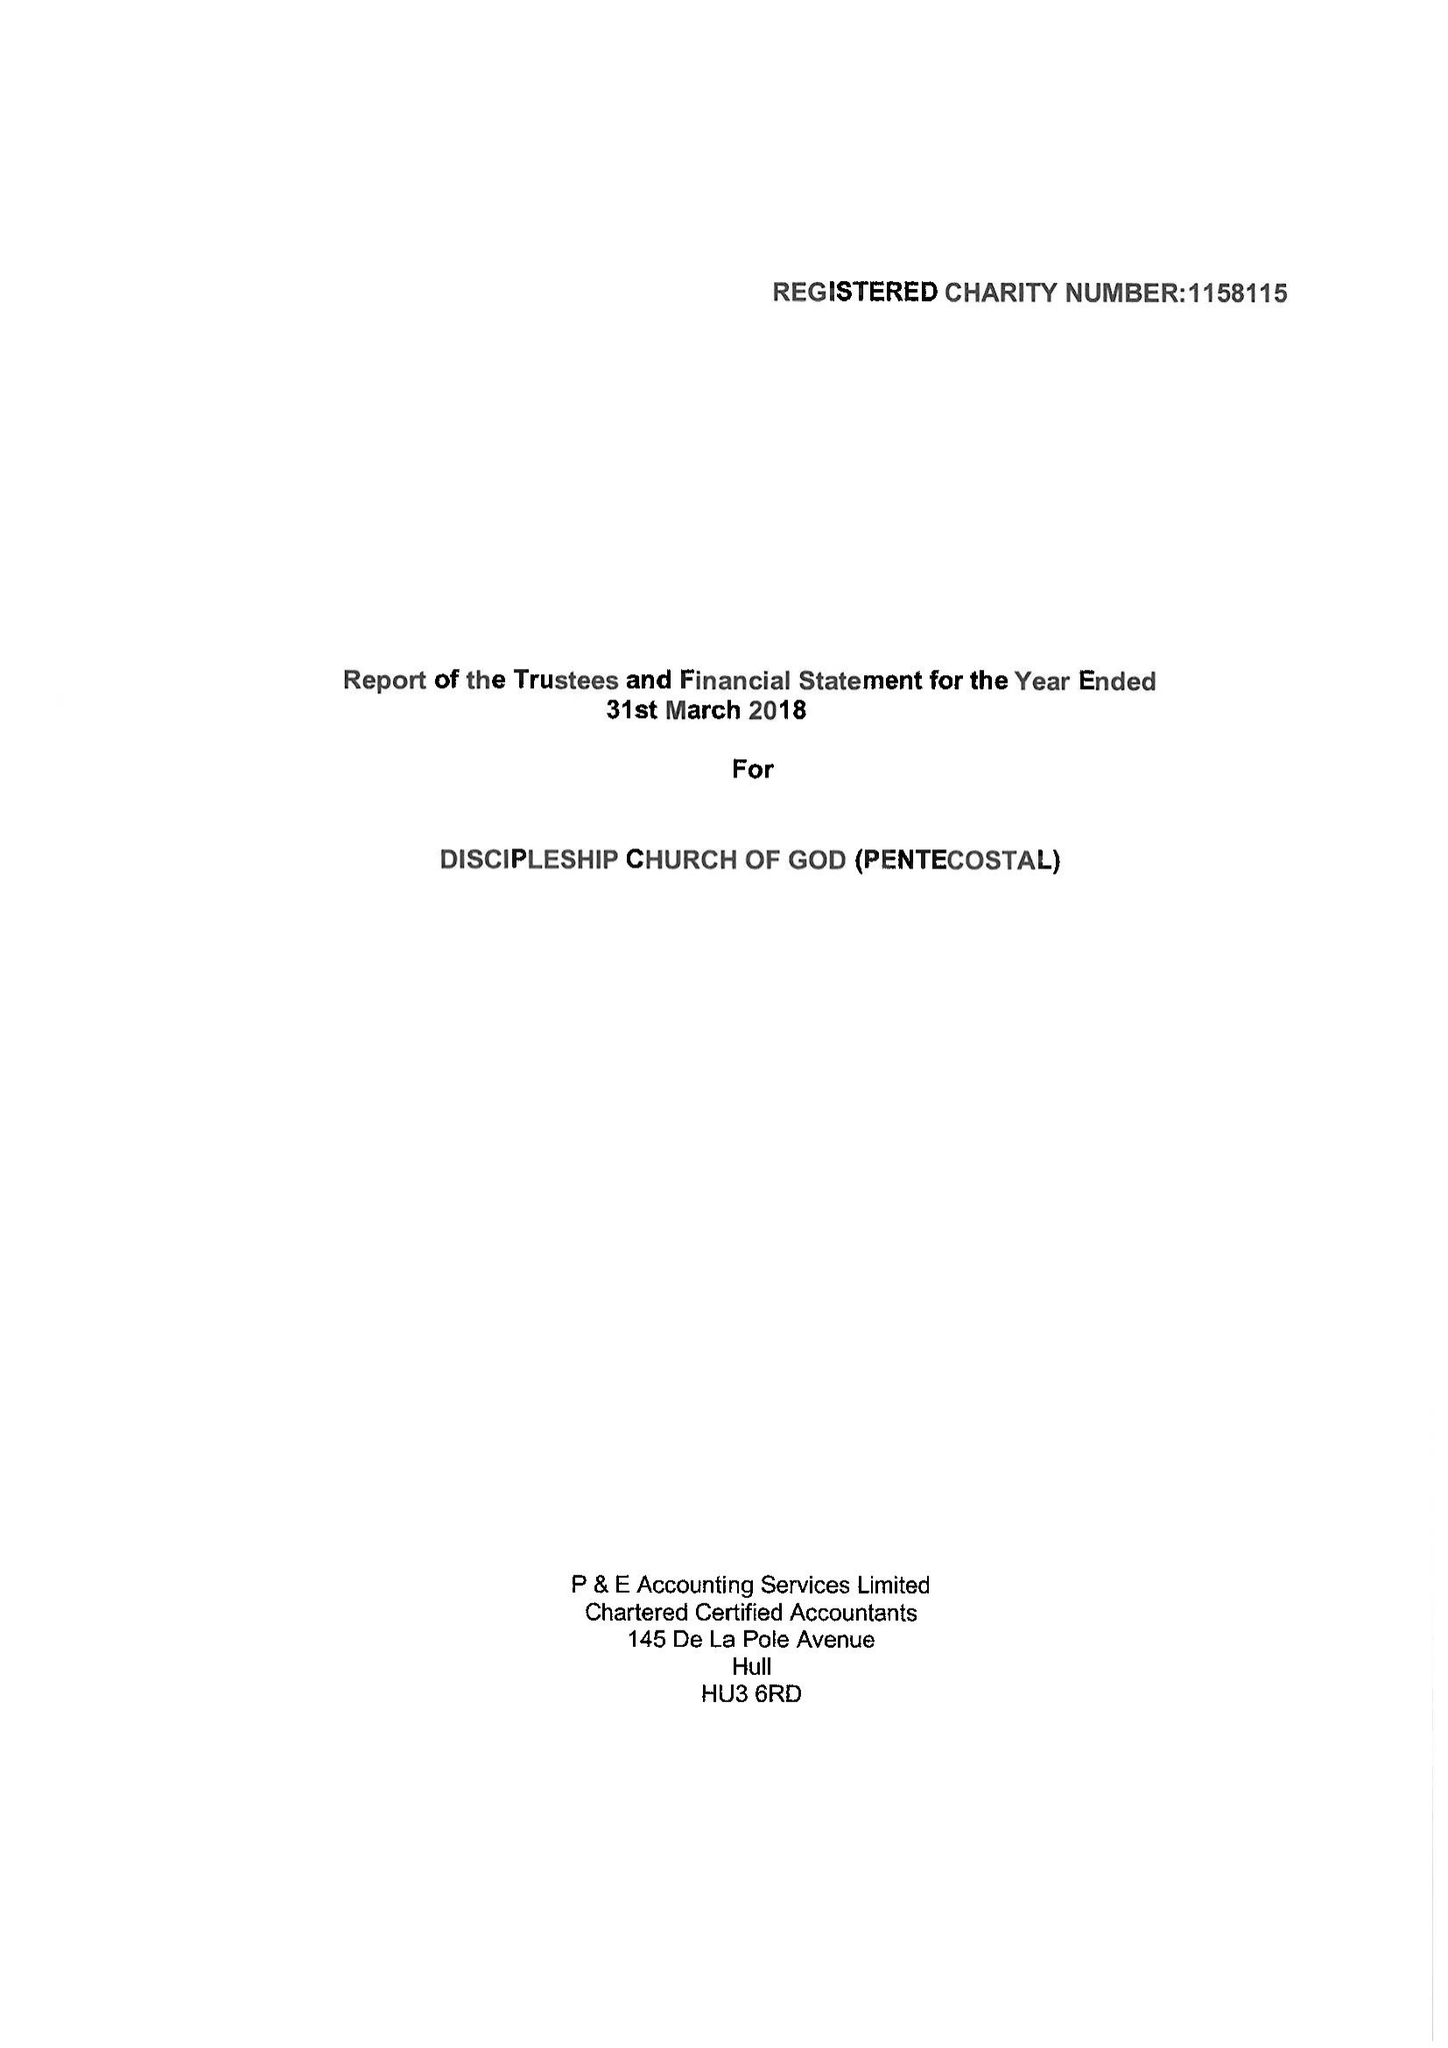What is the value for the report_date?
Answer the question using a single word or phrase. 2018-03-31 